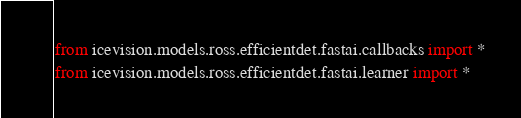<code> <loc_0><loc_0><loc_500><loc_500><_Python_>from icevision.models.ross.efficientdet.fastai.callbacks import *
from icevision.models.ross.efficientdet.fastai.learner import *
</code> 